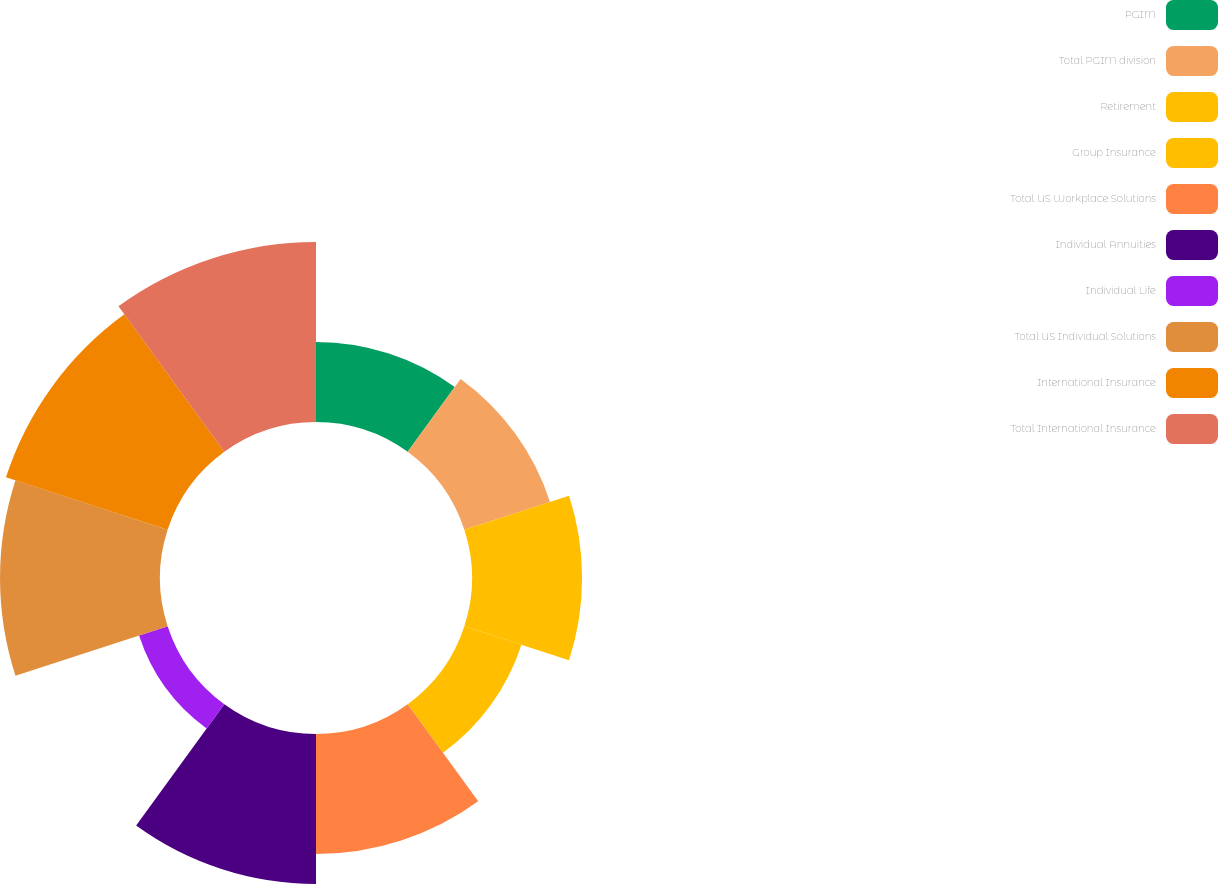Convert chart to OTSL. <chart><loc_0><loc_0><loc_500><loc_500><pie_chart><fcel>PGIM<fcel>Total PGIM division<fcel>Retirement<fcel>Group Insurance<fcel>Total US Workplace Solutions<fcel>Individual Annuities<fcel>Individual Life<fcel>Total US Individual Solutions<fcel>International Insurance<fcel>Total International Insurance<nl><fcel>6.96%<fcel>7.83%<fcel>9.57%<fcel>5.22%<fcel>10.43%<fcel>13.04%<fcel>2.61%<fcel>13.91%<fcel>14.78%<fcel>15.65%<nl></chart> 